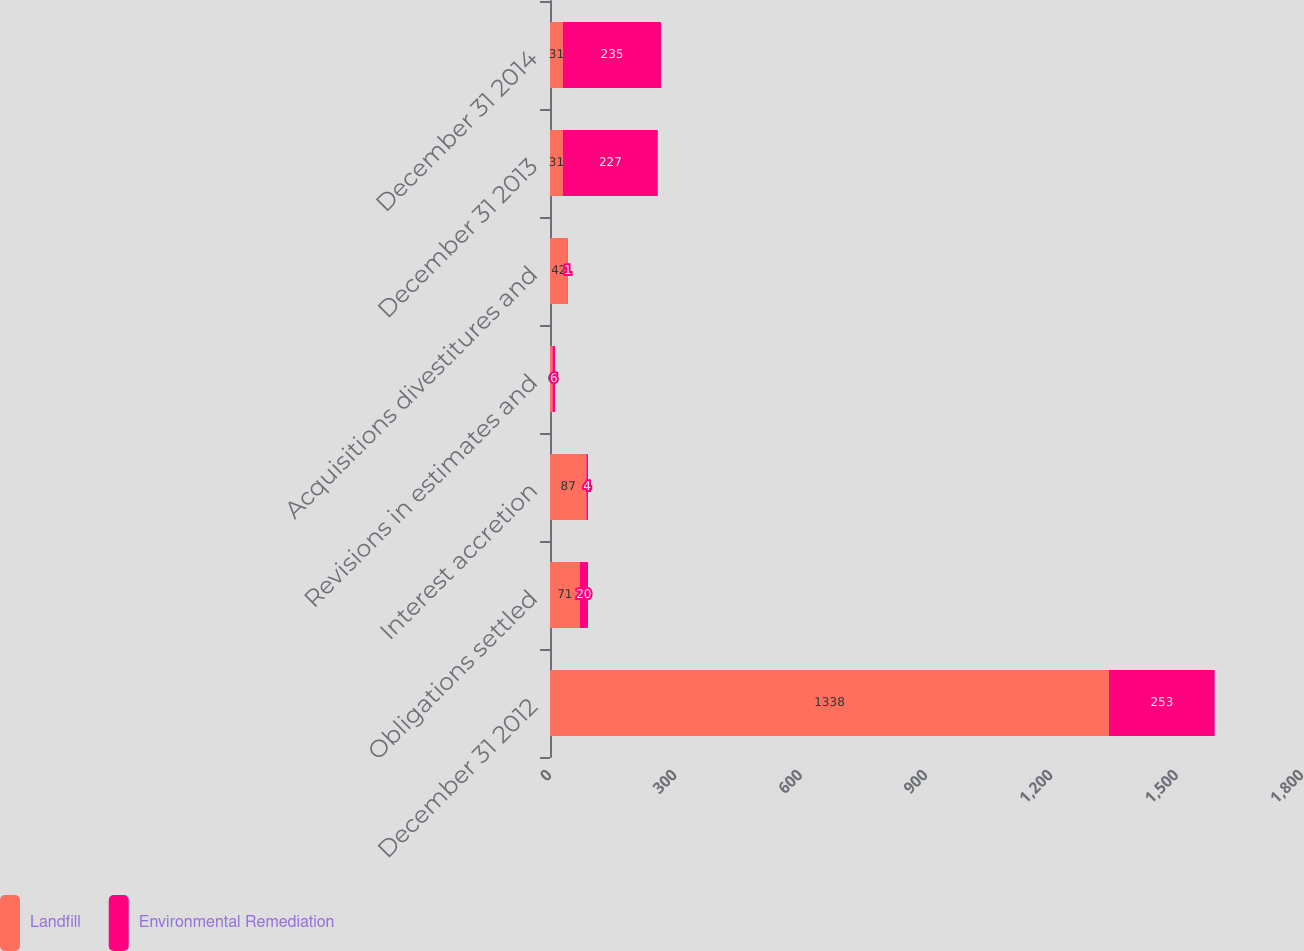Convert chart. <chart><loc_0><loc_0><loc_500><loc_500><stacked_bar_chart><ecel><fcel>December 31 2012<fcel>Obligations settled<fcel>Interest accretion<fcel>Revisions in estimates and<fcel>Acquisitions divestitures and<fcel>December 31 2013<fcel>December 31 2014<nl><fcel>Landfill<fcel>1338<fcel>71<fcel>87<fcel>6<fcel>42<fcel>31<fcel>31<nl><fcel>Environmental Remediation<fcel>253<fcel>20<fcel>4<fcel>6<fcel>1<fcel>227<fcel>235<nl></chart> 